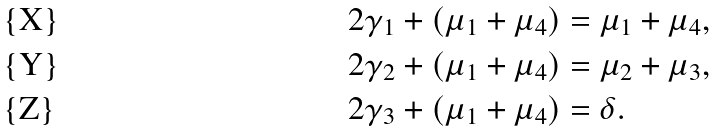Convert formula to latex. <formula><loc_0><loc_0><loc_500><loc_500>2 \gamma _ { 1 } + ( \mu _ { 1 } + \mu _ { 4 } ) & = \mu _ { 1 } + \mu _ { 4 } , \\ 2 \gamma _ { 2 } + ( \mu _ { 1 } + \mu _ { 4 } ) & = \mu _ { 2 } + \mu _ { 3 } , \\ 2 \gamma _ { 3 } + ( \mu _ { 1 } + \mu _ { 4 } ) & = \delta .</formula> 